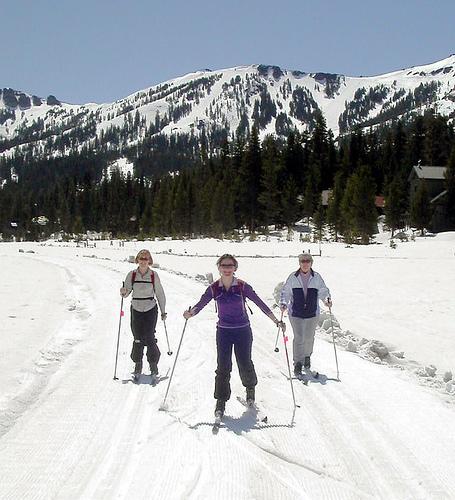Are the skiers at a resort?
Short answer required. Yes. Are the skiers male or female?
Give a very brief answer. Female. Is one woman far behind?
Keep it brief. No. 